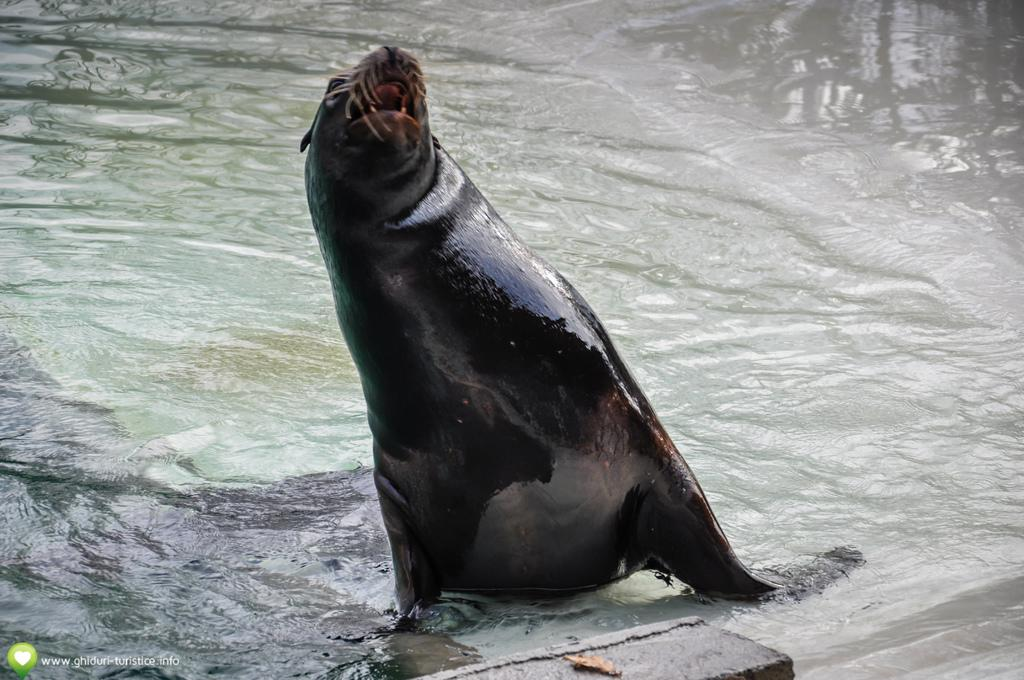What type of animal is in the image? The specific type of animal cannot be determined from the provided facts. What is the primary element visible in the image? Water is visible in the image. What type of gun can be seen in the image? There is no gun present in the image. Is there any blood visible in the image? There is no blood present in the image. 